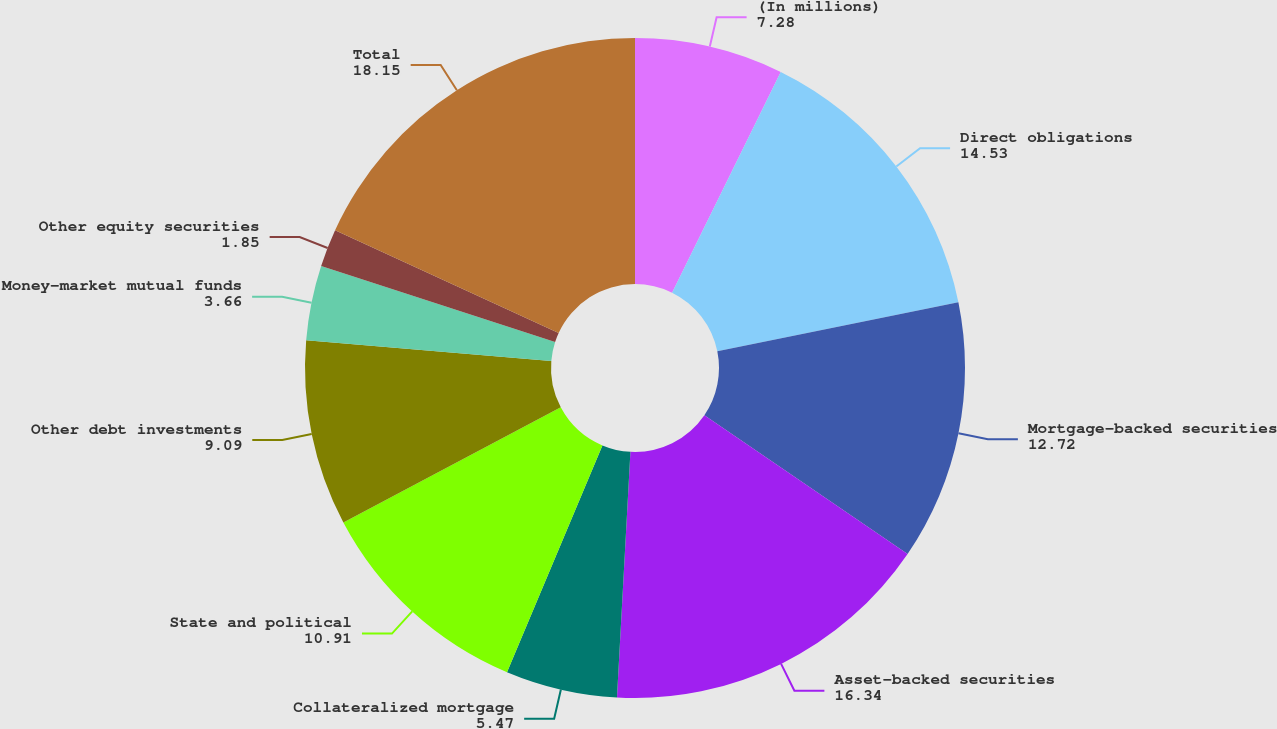<chart> <loc_0><loc_0><loc_500><loc_500><pie_chart><fcel>(In millions)<fcel>Direct obligations<fcel>Mortgage-backed securities<fcel>Asset-backed securities<fcel>Collateralized mortgage<fcel>State and political<fcel>Other debt investments<fcel>Money-market mutual funds<fcel>Other equity securities<fcel>Total<nl><fcel>7.28%<fcel>14.53%<fcel>12.72%<fcel>16.34%<fcel>5.47%<fcel>10.91%<fcel>9.09%<fcel>3.66%<fcel>1.85%<fcel>18.15%<nl></chart> 